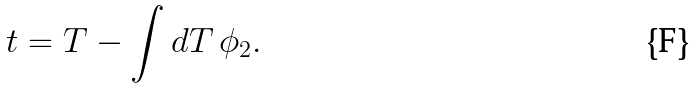<formula> <loc_0><loc_0><loc_500><loc_500>t = T - \int d T \, \phi _ { 2 } .</formula> 